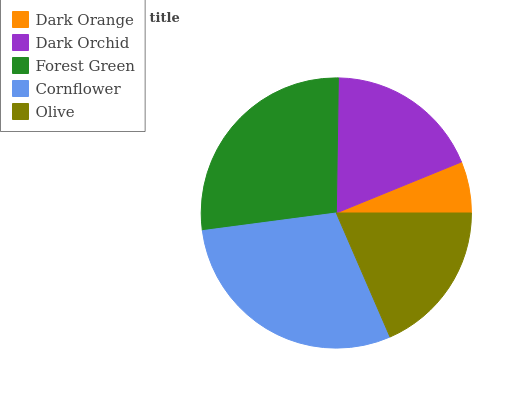Is Dark Orange the minimum?
Answer yes or no. Yes. Is Cornflower the maximum?
Answer yes or no. Yes. Is Dark Orchid the minimum?
Answer yes or no. No. Is Dark Orchid the maximum?
Answer yes or no. No. Is Dark Orchid greater than Dark Orange?
Answer yes or no. Yes. Is Dark Orange less than Dark Orchid?
Answer yes or no. Yes. Is Dark Orange greater than Dark Orchid?
Answer yes or no. No. Is Dark Orchid less than Dark Orange?
Answer yes or no. No. Is Dark Orchid the high median?
Answer yes or no. Yes. Is Dark Orchid the low median?
Answer yes or no. Yes. Is Forest Green the high median?
Answer yes or no. No. Is Olive the low median?
Answer yes or no. No. 